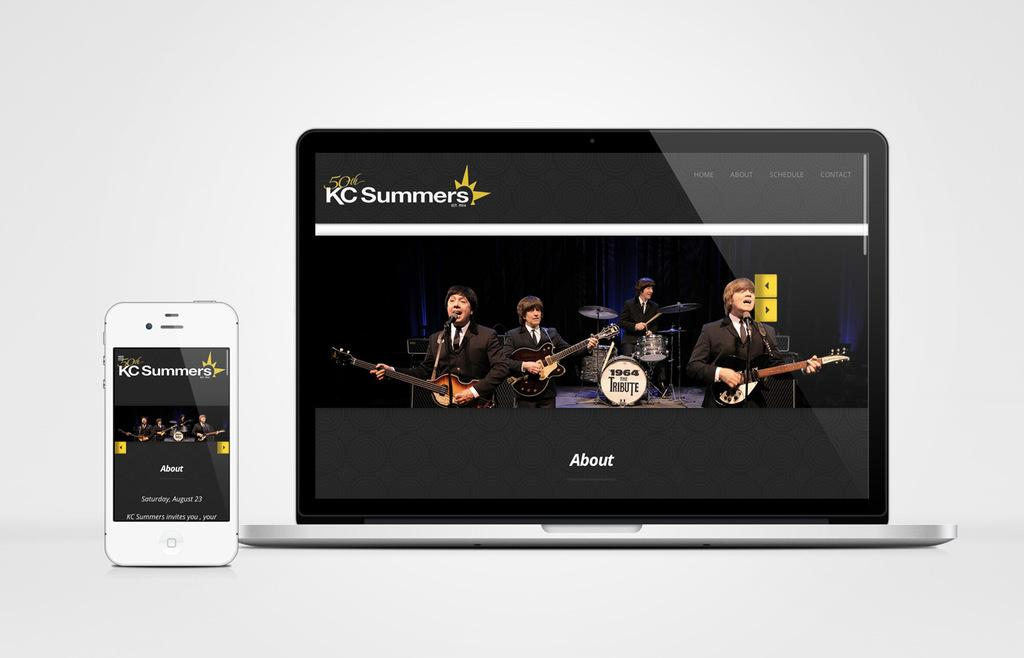<image>
Create a compact narrative representing the image presented. A smart phone and tablet are displaying the KC Summers website. 